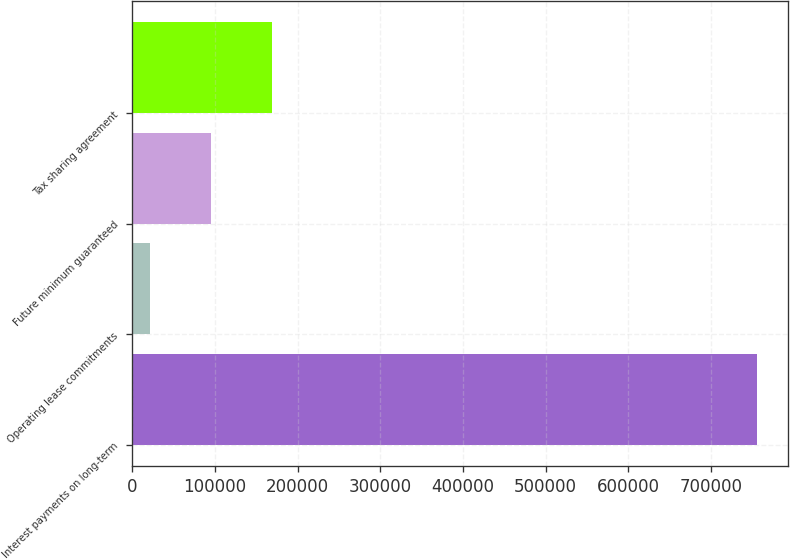<chart> <loc_0><loc_0><loc_500><loc_500><bar_chart><fcel>Interest payments on long-term<fcel>Operating lease commitments<fcel>Future minimum guaranteed<fcel>Tax sharing agreement<nl><fcel>755156<fcel>22146<fcel>95447<fcel>168748<nl></chart> 